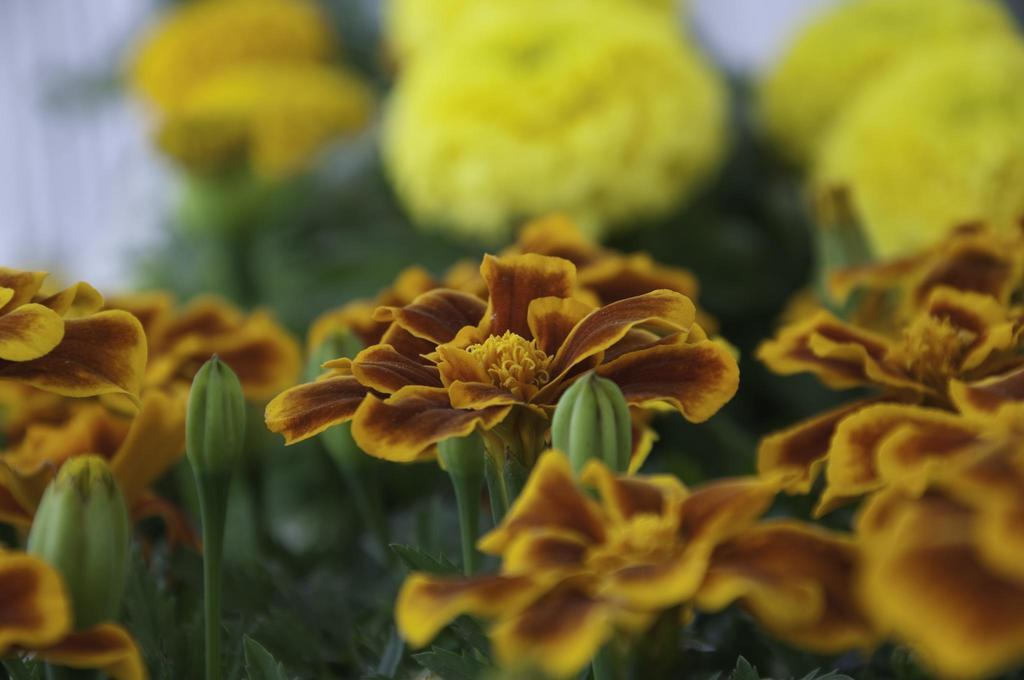What type of living organisms can be seen in the image? There are flowers in the image. Can you describe the stage of growth for some of the flowers? Yes, there are buds in the image. How would you describe the background of the image? The background of the image is blurred. What type of pie is being served on a plate in the image? There is no pie present in the image; it features flowers and buds. Can you describe the body language of the flowers in the image? The flowers in the image do not have body language, as they are inanimate objects. 